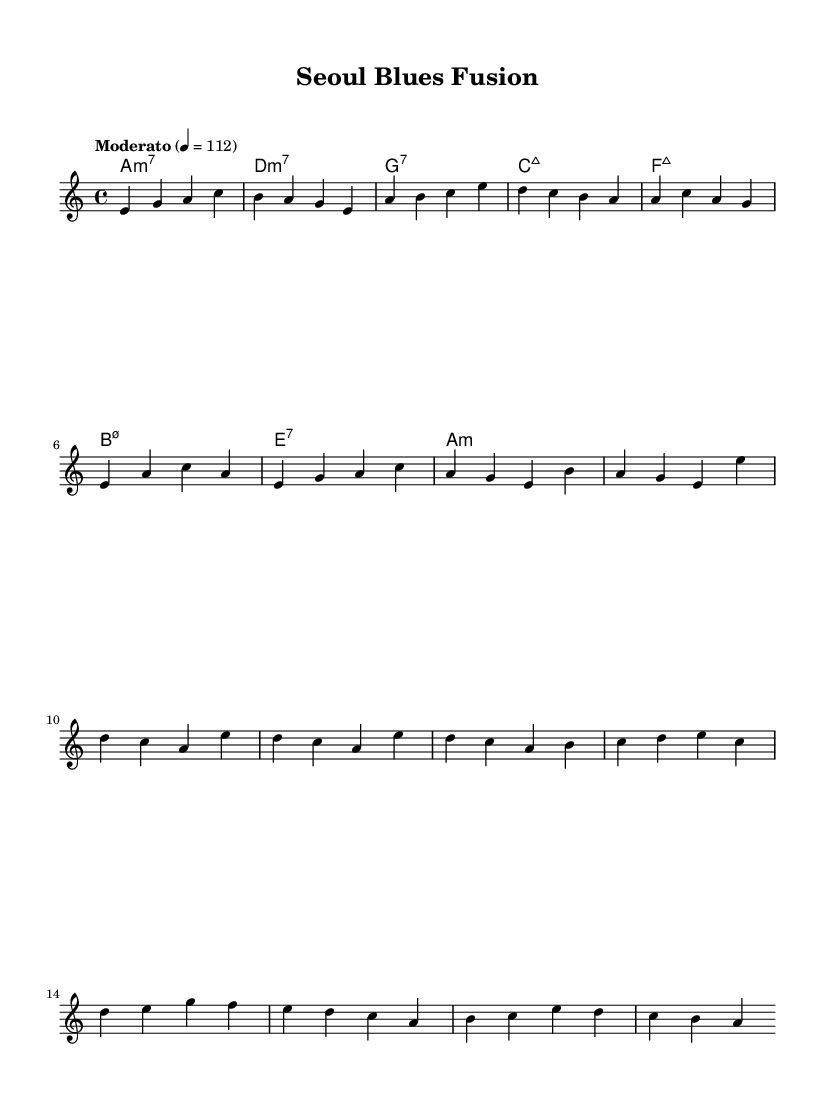What is the key signature of this music? The key signature is A minor, which contains no sharps and has the relative major key of C major. We can identify this by looking for the key indication at the beginning of the score, which shows "a" indicating A minor.
Answer: A minor What is the time signature of this music? The time signature is 4/4, which indicates that there are four beats in each measure, and a quarter note receives one beat. This can be determined by looking at the notation directly after the key signature.
Answer: 4/4 What is the tempo marking of this piece? The tempo marking is "Moderato," which suggests a moderate speed for the piece. The specified metronome marking "4 = 112" indicates the beats per minute, giving further context to the pacing of the music.
Answer: Moderato How many measures are in the chorus section? The chorus section consists of four measures, as seen in the repetition of the melodic lines indicated in that part of the score. Each line indicates a single measure, and there are four such lines in the chorus segment.
Answer: 4 What is the last chord of the piece? The last chord of the piece is A minor, identified from the harmonies section where the final chord is listed at the end of the score. This is determined by reviewing the chord names in conjunction with the melody.
Answer: A minor How does the melody begin in the intro? The melody begins with the notes E, G, A, and C. This sequence is noted at the start of the melody section, where each note corresponds to the first four beats of the introduction.
Answer: E, G, A, C 